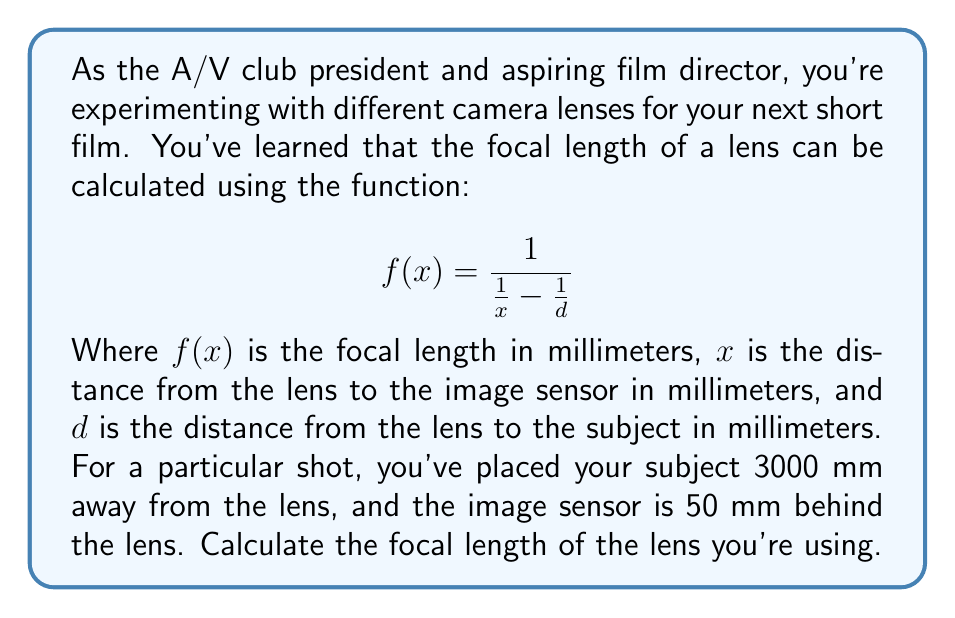Can you answer this question? Let's approach this step-by-step:

1) We're given the function for focal length:
   $$ f(x) = \frac{1}{\frac{1}{x} - \frac{1}{d}} $$

2) We know the following values:
   - $d = 3000$ mm (distance from lens to subject)
   - $x = 50$ mm (distance from lens to image sensor)

3) Let's substitute these values into our function:
   $$ f(50) = \frac{1}{\frac{1}{50} - \frac{1}{3000}} $$

4) Now, let's solve this step-by-step:
   
   a) First, calculate the fractions inside the parentheses:
      $\frac{1}{50} = 0.02$ and $\frac{1}{3000} \approx 0.000333$
   
   b) Subtract these:
      $0.02 - 0.000333 = 0.019667$
   
   c) Now our equation looks like:
      $$ f(50) = \frac{1}{0.019667} $$

   d) Calculate the final result:
      $$ f(50) \approx 50.85 $$

5) Therefore, the focal length is approximately 50.85 mm.
Answer: The focal length of the lens is approximately 50.85 mm. 